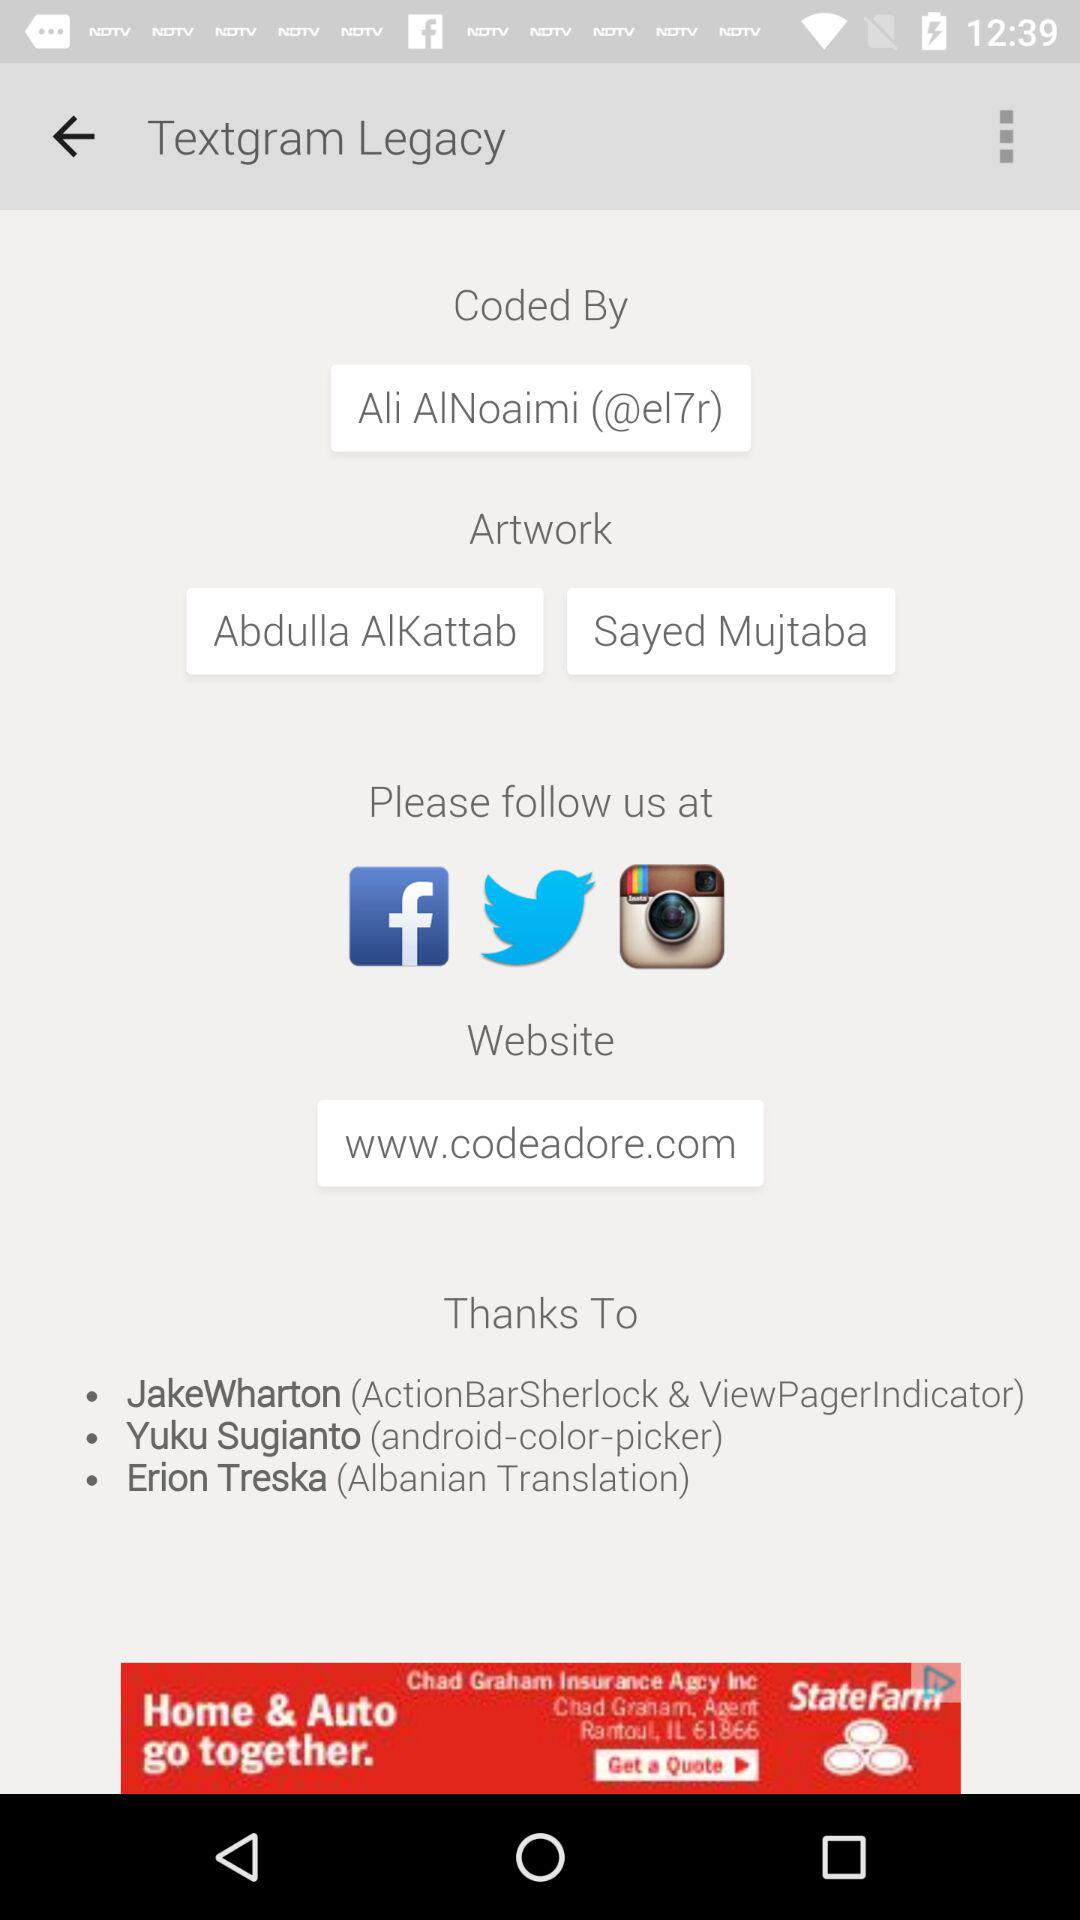What is the name of the application? The name of the application is "Textgram Legacy". 